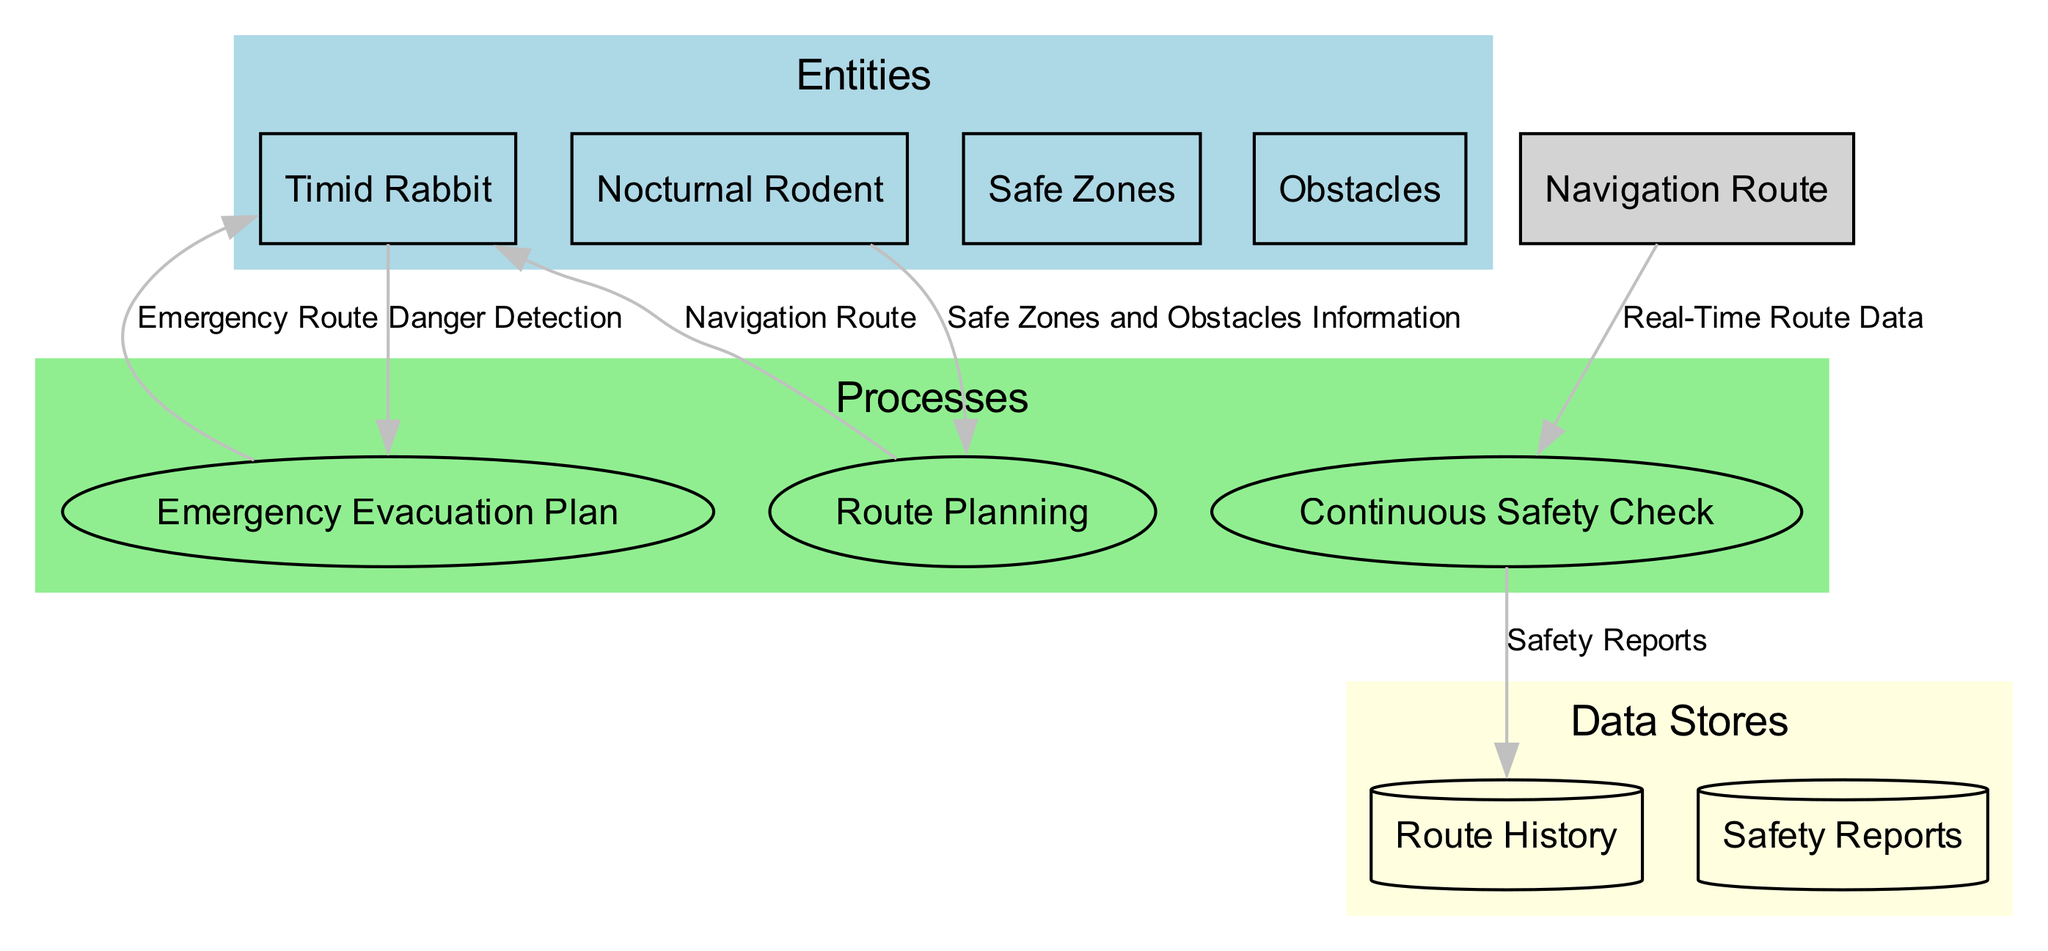What is the main entity involved in nighttime navigation? The diagram identifies the "Timid Rabbit" as the main navigator who seeks safety during nighttime travels. This can be found in the "Entities" section of the diagram.
Answer: Timid Rabbit How many processes are involved in the navigation flow? The diagram lists three distinct processes: "Route Planning," "Continuous Safety Check," and "Emergency Evacuation Plan." Counting these processes provides the total number involved in the navigation flow.
Answer: Three Which entity provides information to the "Route Planning" process? The "Nocturnal Rodent" is identified as the source of information provided to the "Route Planning" process, specifically regarding safe zones and obstacles. This relationship is reflected in the data flow from the entity to the process.
Answer: Nocturnal Rodent What does the "Continuous Safety Check" process monitor? The "Continuous Safety Check" process is shown to monitor "Real-Time Route Data," ensuring that the navigation route remains safe during travel. This is indicated by the data flow connecting the navigation route to this process.
Answer: Real-Time Route Data What is the output of the "Emergency Evacuation Plan" process? The output of the "Emergency Evacuation Plan" process is the "Emergency Route," which is provided to the "Timid Rabbit" when danger is detected, as shown in the diagram.
Answer: Emergency Route How does "Route History" receive information? "Route History" receives information through data flow from the "Continuous Safety Check" process, which logs the safety reports and real-time navigation data. This connection illustrates how this data store is updated.
Answer: Safety Reports What are the inputs for the "Route Planning" process? The inputs for the "Route Planning" process are specifically identified as "Nocturnal Rodent," "Safe Zones," and "Obstacles," as indicated in the process's description and diagram flow.
Answer: Nocturnal Rodent, Safe Zones, Obstacles What happens when danger is detected by the "Timid Rabbit"? When danger is detected, it triggers the "Emergency Evacuation Plan" process, which produces an "Emergency Route" to ensure safety. This action is depicted in the flow from the "Timid Rabbit" to the process.
Answer: Emergency Evacuation Plan 